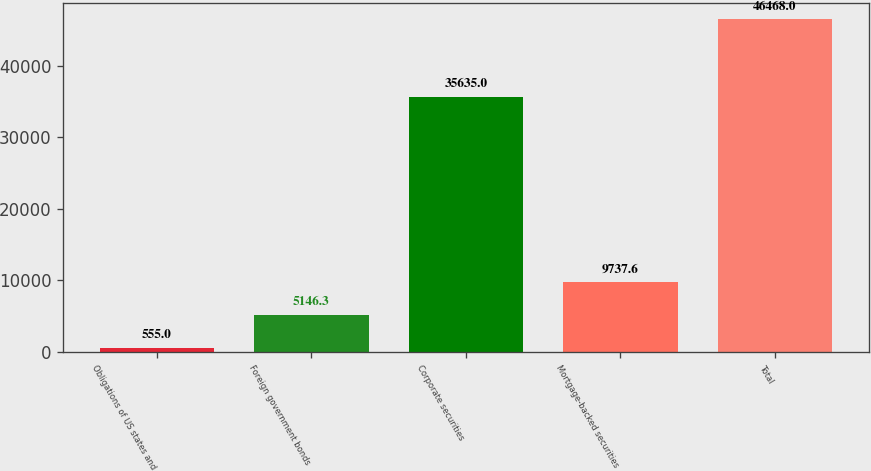Convert chart to OTSL. <chart><loc_0><loc_0><loc_500><loc_500><bar_chart><fcel>Obligations of US states and<fcel>Foreign government bonds<fcel>Corporate securities<fcel>Mortgage-backed securities<fcel>Total<nl><fcel>555<fcel>5146.3<fcel>35635<fcel>9737.6<fcel>46468<nl></chart> 